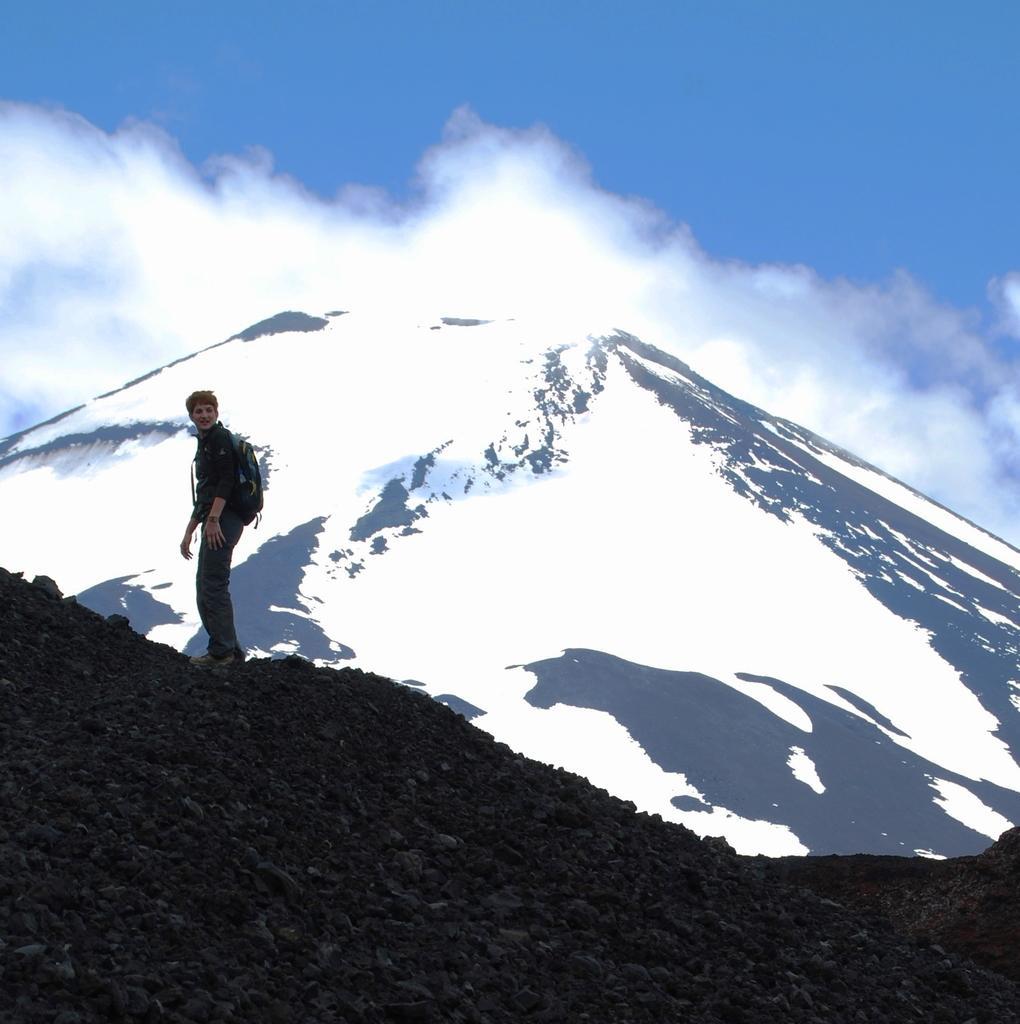Can you describe this image briefly? On the left side a person is standing, he wore shirt, trouser, bag. On the right side there is a mountain with the snow, at the top it is the sky. 